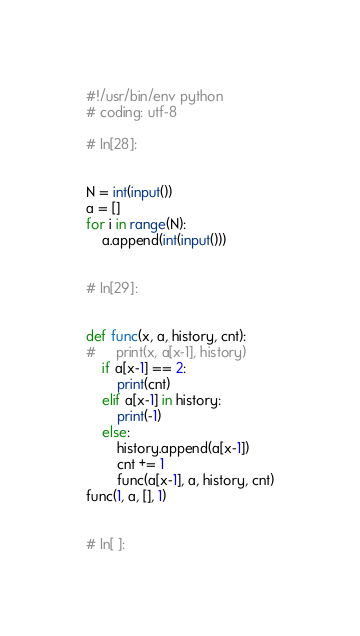Convert code to text. <code><loc_0><loc_0><loc_500><loc_500><_Python_>#!/usr/bin/env python
# coding: utf-8

# In[28]:


N = int(input())
a = []
for i in range(N):
    a.append(int(input()))


# In[29]:


def func(x, a, history, cnt):
#     print(x, a[x-1], history)
    if a[x-1] == 2:
        print(cnt)
    elif a[x-1] in history:
        print(-1)
    else:
        history.append(a[x-1])
        cnt += 1
        func(a[x-1], a, history, cnt)
func(1, a, [], 1)


# In[ ]:




</code> 